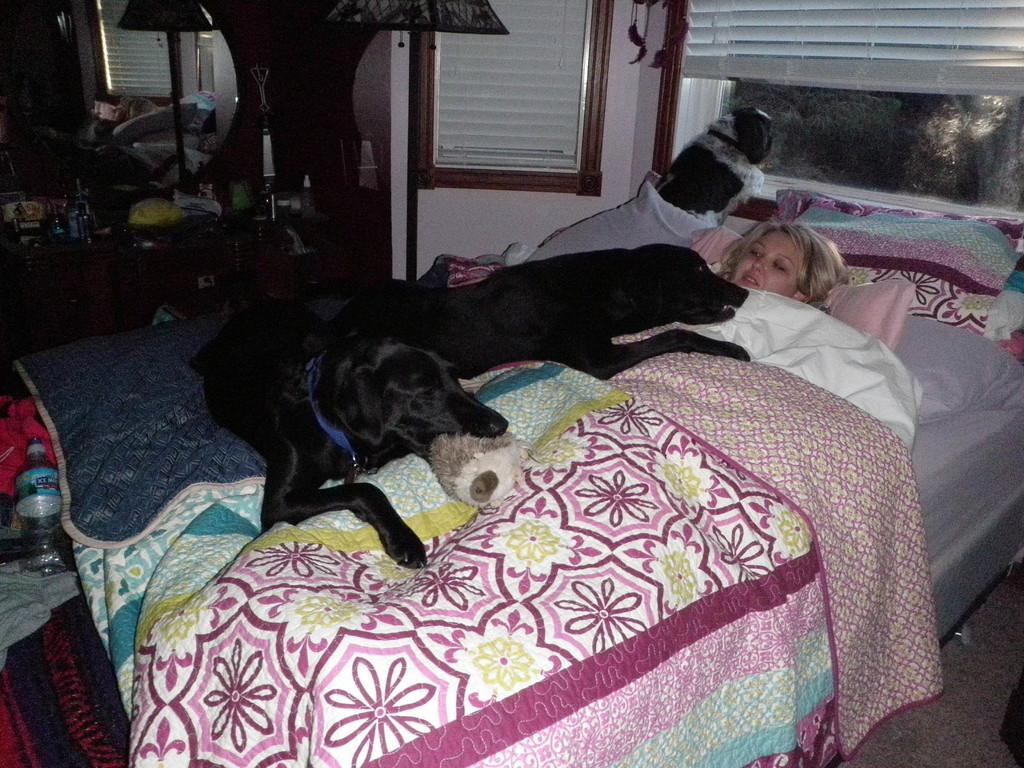What type of lighting fixture is present in the image? There is a lamp in the image. What architectural feature is visible in the image? There is a window in the image. What piece of furniture is in the image? There is a bed in the image. What is on the bed? There are pillows on the bed. Who is on the bed? A woman is lying on the bed. How many dogs are in the image? There are three dogs in the image. What type of bear can be seen playing with the drain in the image? There is no bear or drain present in the image. What decision is the woman making in the image? The image does not provide any information about a decision being made by the woman. 